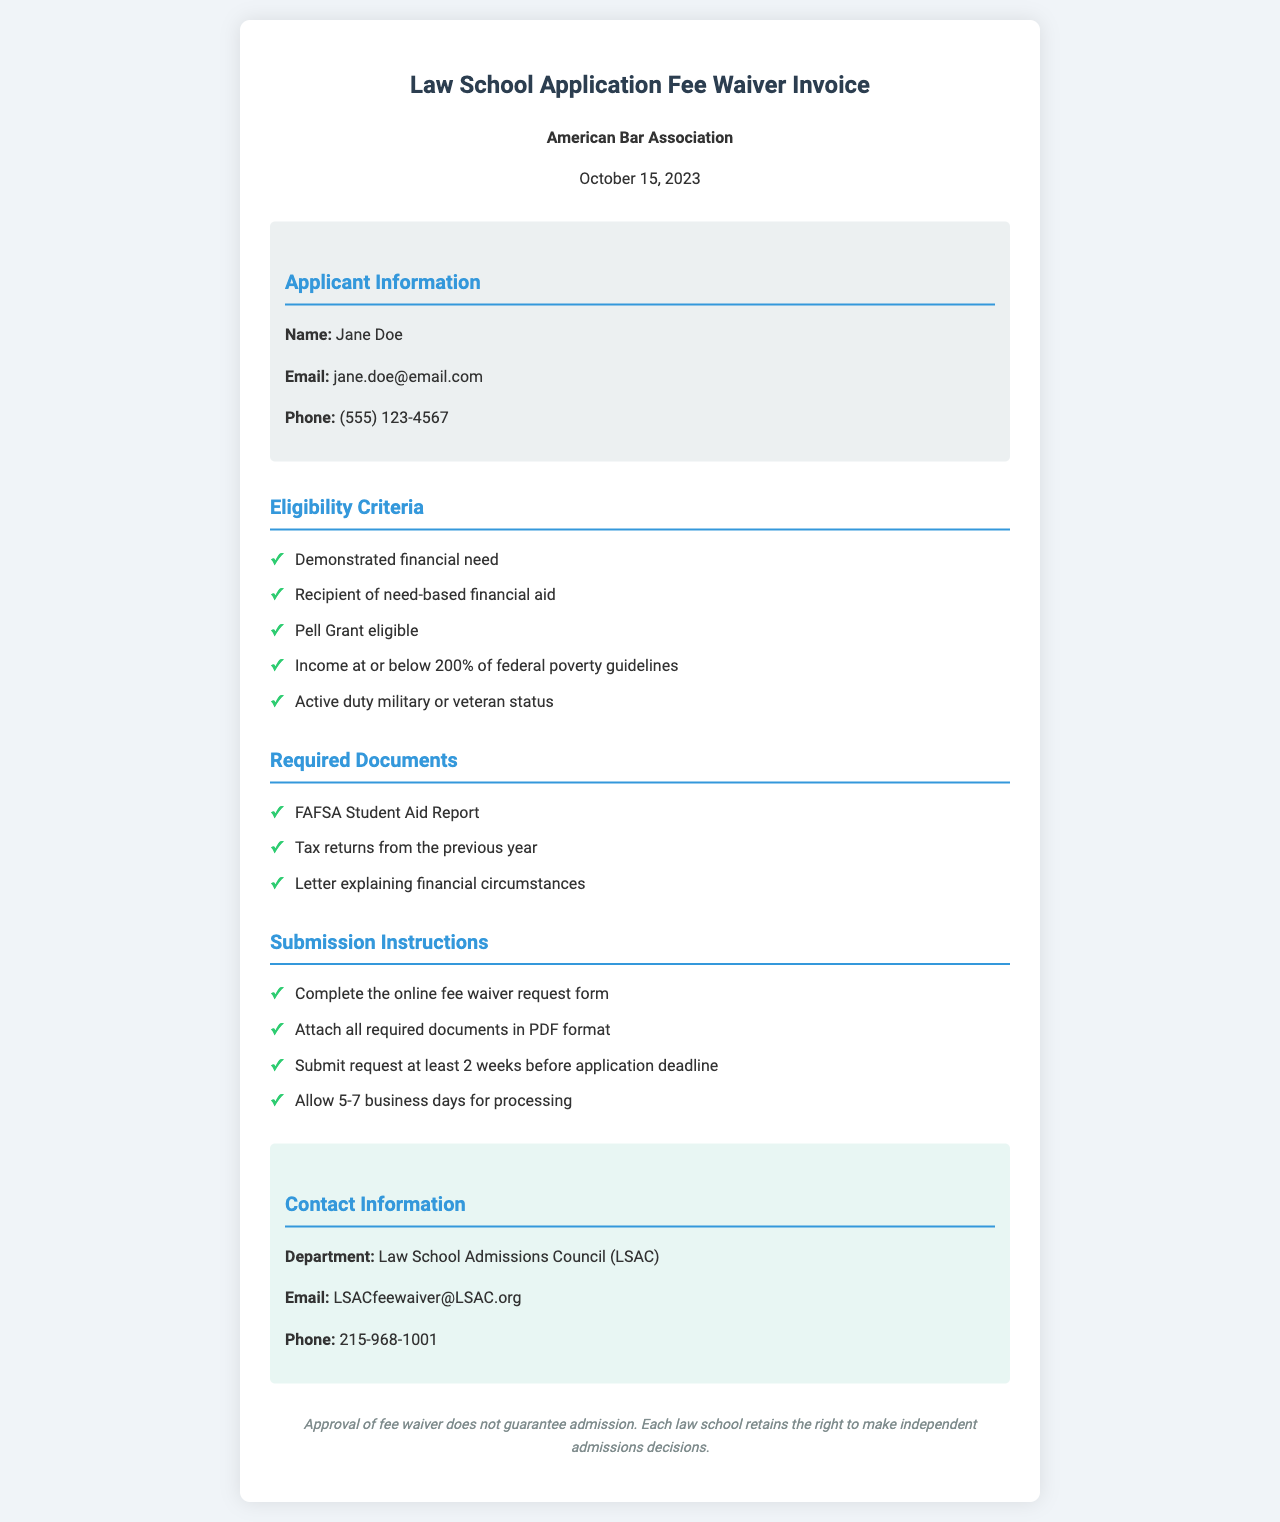What is the name of the applicant? The applicant's name is mentioned under the applicant information section of the document.
Answer: Jane Doe What is the date of the invoice? The invoice date is specified at the top of the document, indicating when it was created.
Answer: October 15, 2023 What financial aid is mentioned in the eligibility criteria? The eligibility criteria include specific types of financial aid that qualify for the fee waiver.
Answer: need-based financial aid How long does it take for processing of the fee waiver request? The document specifies a time frame for processing requests in the submission instructions section.
Answer: 5-7 business days Which document is not required for submission? This question requires recalling the content of the required documents list in the document.
Answer: None (all listed are required) What is the email address for contacting the admissions council? The contact information section provides an email address for inquiries.
Answer: LSACfeewaiver@LSAC.org What income level is specified in the eligibility criteria? The income level mentioned in the eligibility criteria indicates a specific percentage of federal poverty guidelines.
Answer: 200% What should be attached to the online fee waiver request form? The submission instructions indicate what additional documents need to be attached to the request.
Answer: required documents in PDF format Which department handles the fee waivers? The document specifies the department responsible for managing the fee waiver requests.
Answer: Law School Admissions Council (LSAC) 